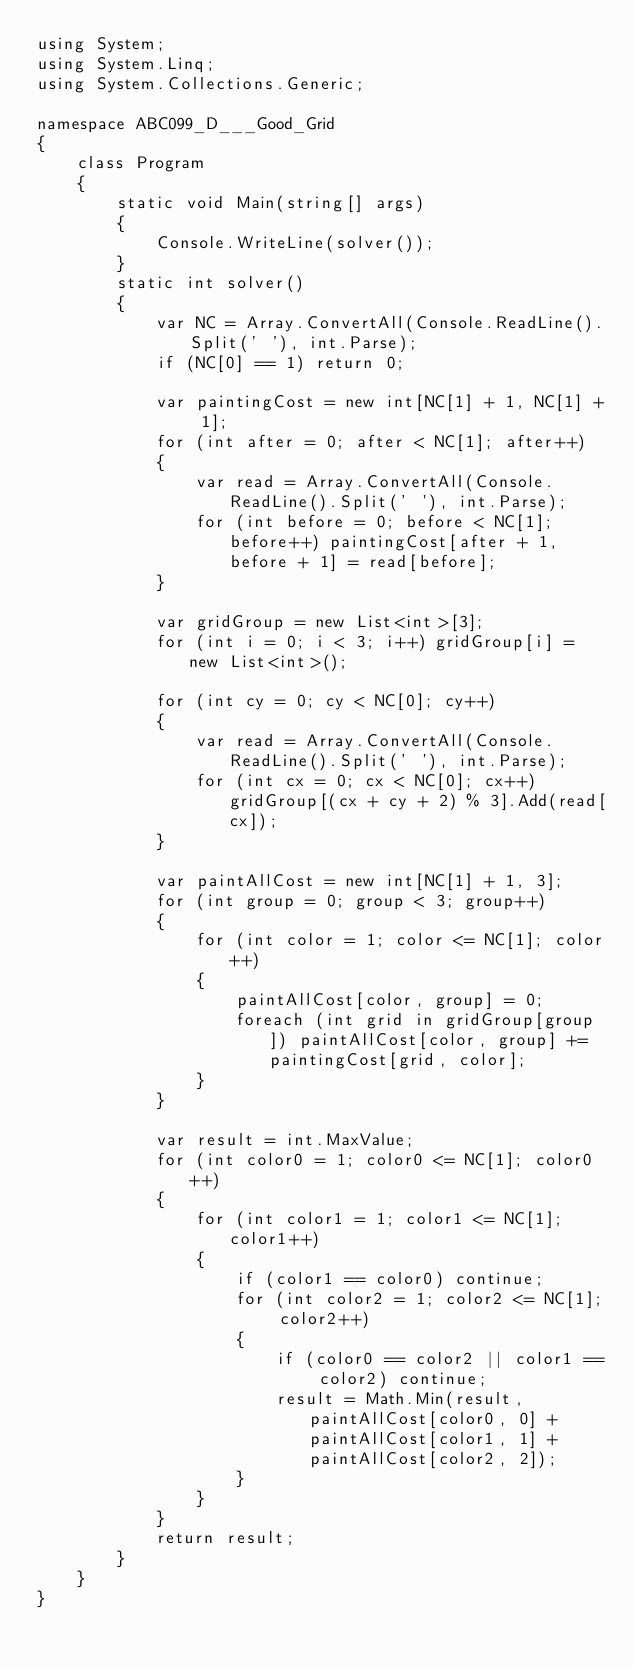<code> <loc_0><loc_0><loc_500><loc_500><_C#_>using System;
using System.Linq;
using System.Collections.Generic;

namespace ABC099_D___Good_Grid
{
    class Program
    {
        static void Main(string[] args)
        {
            Console.WriteLine(solver());
        }
        static int solver()
        {
            var NC = Array.ConvertAll(Console.ReadLine().Split(' '), int.Parse);
            if (NC[0] == 1) return 0;

            var paintingCost = new int[NC[1] + 1, NC[1] + 1];
            for (int after = 0; after < NC[1]; after++)
            {
                var read = Array.ConvertAll(Console.ReadLine().Split(' '), int.Parse);
                for (int before = 0; before < NC[1]; before++) paintingCost[after + 1, before + 1] = read[before];
            }

            var gridGroup = new List<int>[3];
            for (int i = 0; i < 3; i++) gridGroup[i] = new List<int>();

            for (int cy = 0; cy < NC[0]; cy++)
            {
                var read = Array.ConvertAll(Console.ReadLine().Split(' '), int.Parse);
                for (int cx = 0; cx < NC[0]; cx++) gridGroup[(cx + cy + 2) % 3].Add(read[cx]);
            }

            var paintAllCost = new int[NC[1] + 1, 3];
            for (int group = 0; group < 3; group++)
            {
                for (int color = 1; color <= NC[1]; color++)
                {
                    paintAllCost[color, group] = 0;
                    foreach (int grid in gridGroup[group]) paintAllCost[color, group] += paintingCost[grid, color];
                }
            }

            var result = int.MaxValue;
            for (int color0 = 1; color0 <= NC[1]; color0++)
            {
                for (int color1 = 1; color1 <= NC[1]; color1++)
                {
                    if (color1 == color0) continue;
                    for (int color2 = 1; color2 <= NC[1]; color2++)
                    {
                        if (color0 == color2 || color1 == color2) continue;
                        result = Math.Min(result, paintAllCost[color0, 0] + paintAllCost[color1, 1] + paintAllCost[color2, 2]);
                    }
                }
            }
            return result;
        }
    }
}
</code> 